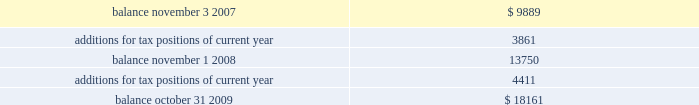Included in other non-current liabilities , because the company believes that the ultimate payment or settlement of these liabilities will not occur within the next twelve months .
Prior to the adoption of these provisions , these amounts were included in current income tax payable .
The company includes interest and penalties related to unrecognized tax benefits within the provision for taxes in the condensed consolidated statements of income , and as a result , no change in classification was made upon adopting these provisions .
The condensed consolidated statements of income for fiscal year 2009 and fiscal year 2008 include $ 1.7 million and $ 1.3 million , respectively , of interest and penalties related to these uncertain tax positions .
Due to the complexity associated with its tax uncertainties , the company cannot make a reasonably reliable estimate as to the period in which it expects to settle the liabilities associated with these uncertain tax positions .
The table summarizes the changes in the total amounts of uncertain tax positions for fiscal 2008 and fiscal 2009. .
Fiscal year 2004 and 2005 irs examination during the fourth quarter of fiscal 2007 , the irs completed its field examination of the company 2019s fiscal years 2004 and 2005 .
On january 2 , 2008 , the irs issued its report for fiscal 2004 and 2005 , which included proposed adjustments related to these two fiscal years .
The company has recorded taxes and penalties related to certain of these proposed adjustments .
There are four items with an additional potential total tax liability of $ 46 million .
The company has concluded , based on discussions with its tax advisors , that these four items are not likely to result in any additional tax liability .
Therefore , the company has not recorded any additional tax liability for these items and is appealing these proposed adjustments through the normal processes for the resolution of differences between the irs and taxpayers .
The company 2019s initial meetings with the appellate division of the irs were held during fiscal year 2009 .
Two of the unresolved matters are one-time issues and pertain to section 965 of the internal revenue code related to the beneficial tax treatment of dividends from foreign owned companies under the american jobs creation act .
The other matters pertain to the computation of research and development ( r&d ) tax credits and the profits earned from manufacturing activities carried on outside the united states .
These latter two matters could impact taxes payable for fiscal 2004 and 2005 as well as for subsequent years .
Fiscal year 2006 and 2007 irs examination during the third quarter of fiscal 2009 , the irs completed its field examination of the company 2019s fiscal years 2006 and 2007 .
The irs and the company have agreed on the treatment of a number of issues that have been included in an issue resolutions agreement related to the 2006 and 2007 tax returns .
However , no agreement was reached on the tax treatment of a number of issues , including the same r&d credit and foreign manufacturing issues mentioned above related to fiscal 2004 and 2005 , the pricing of intercompany sales ( transfer pricing ) , and the deductibility of certain stock option compensation expenses .
During the third quarter of fiscal 2009 , the irs issued its report for fiscal 2006 and fiscal 2007 , which included proposed adjustments related to these two fiscal years .
The company has recorded taxes and penalties related to certain of these proposed adjustments .
There are four items with an additional potential total tax liability of $ 195 million .
The company concluded , based on discussions with its tax advisors , that these four items are not likely to result in any additional tax liability .
Therefore , the company has not recorded any additional tax liability for these items and is appealing these proposed adjustments through the normal processes for the resolution of differences between the irs and taxpayers .
With the exception of the analog devices , inc .
Notes to consolidated financial statements 2014 ( continued ) .
What would be the balance if the company suffered the potential total tax liability of the 2006 and 2007 irs examination? 
Rationale: the potential tax liability for the 2006 and 2007 irs examination would be 195 million . to find the final balance one would take the balance and subtract this number
Computations: (18161 - 195)
Answer: 17966.0. 